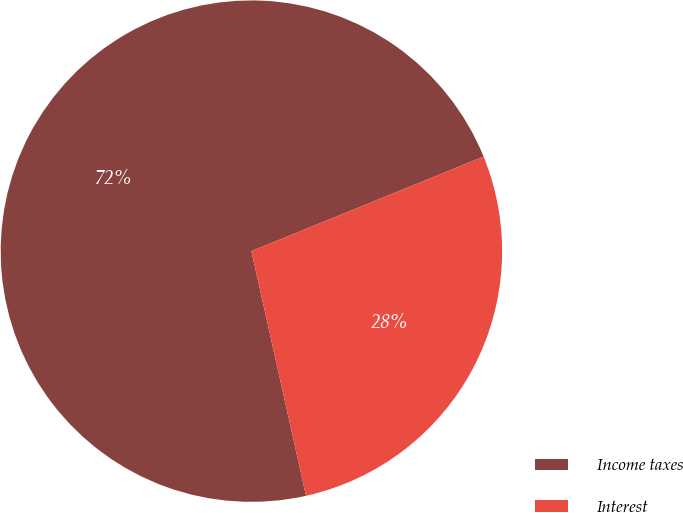Convert chart. <chart><loc_0><loc_0><loc_500><loc_500><pie_chart><fcel>Income taxes<fcel>Interest<nl><fcel>72.34%<fcel>27.66%<nl></chart> 